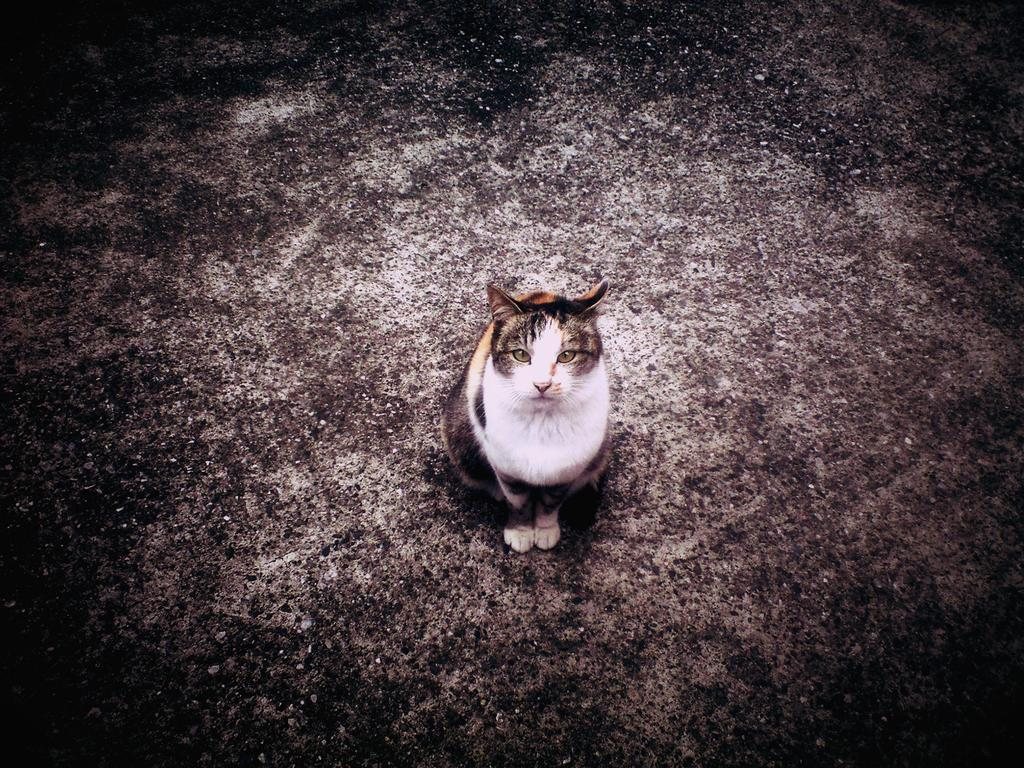What type of animal is in the image? There is a cat in the image. Where is the cat located in the image? The cat is on a surface. What type of oil can be seen dripping from the cat in the image? There is no oil present in the image, and the cat is not depicted as dripping anything. 